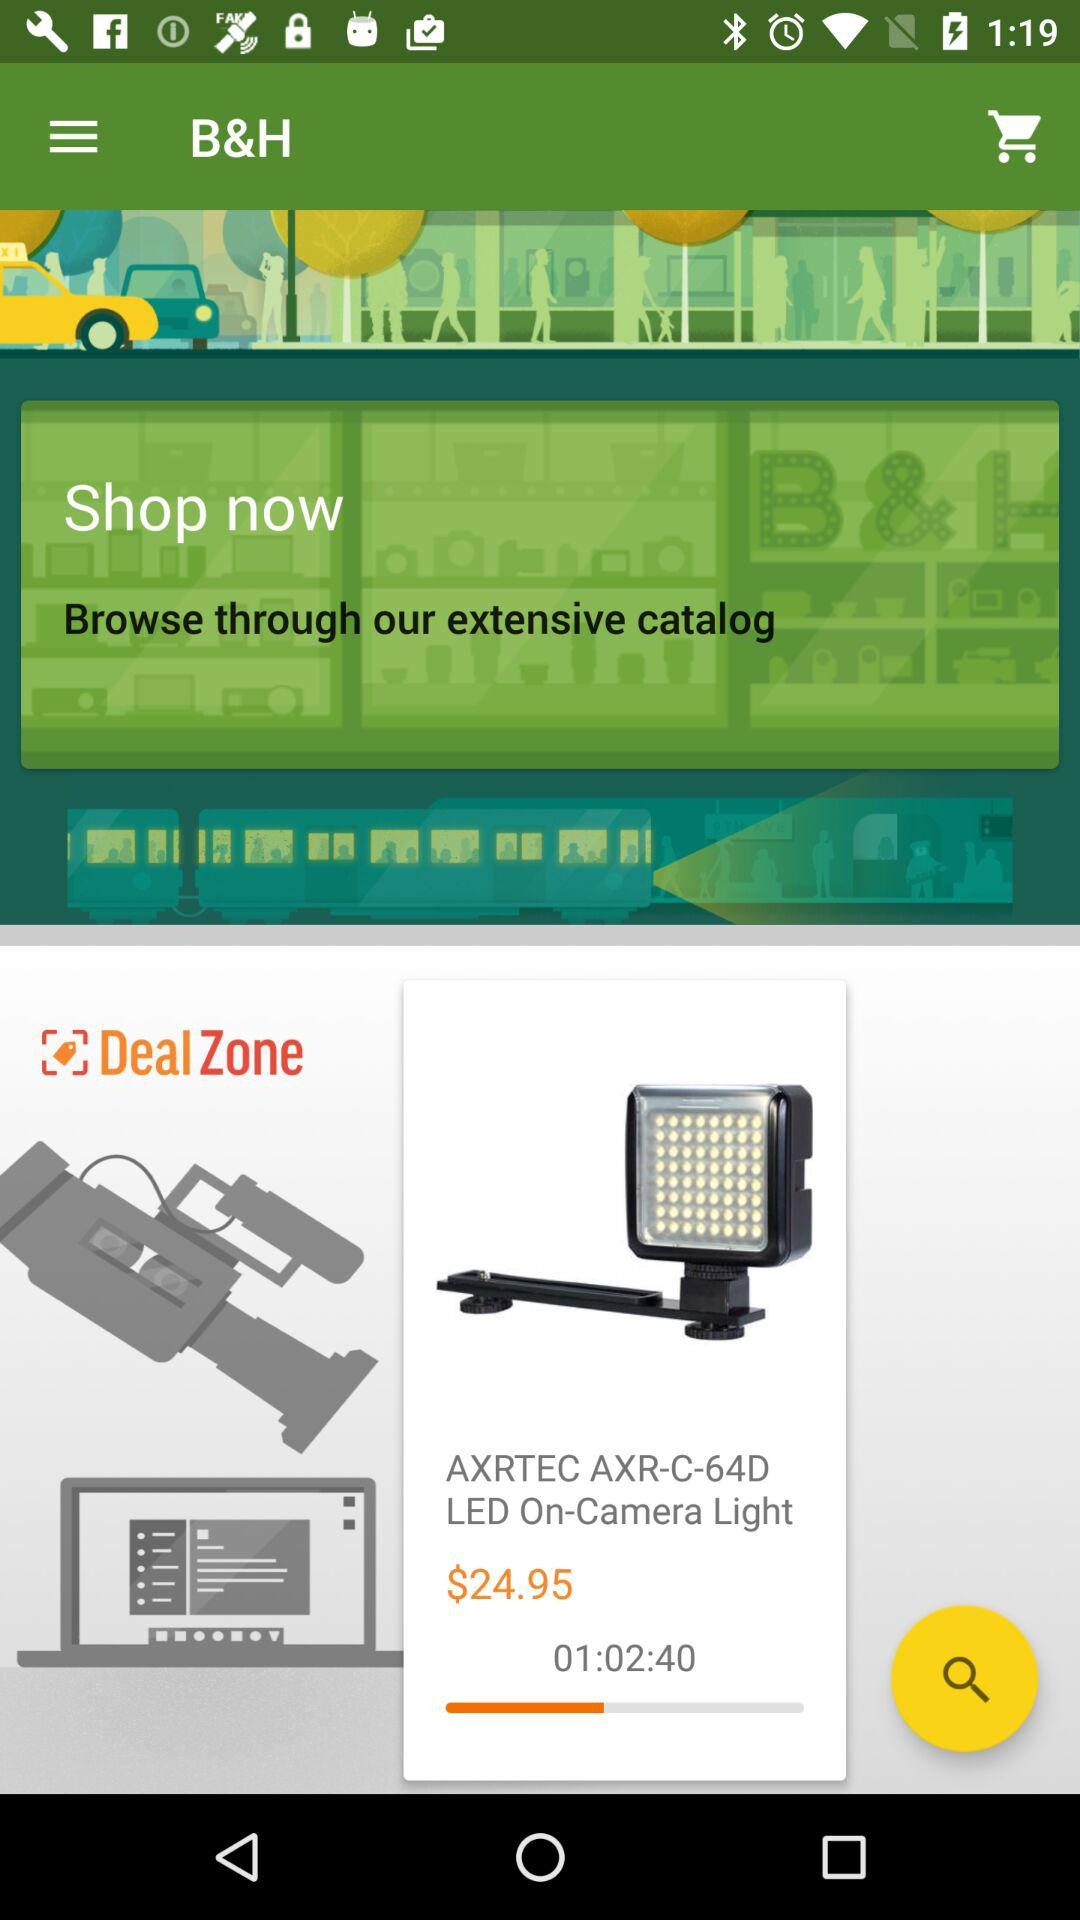How much is the projector?
Answer the question using a single word or phrase. $24.95 